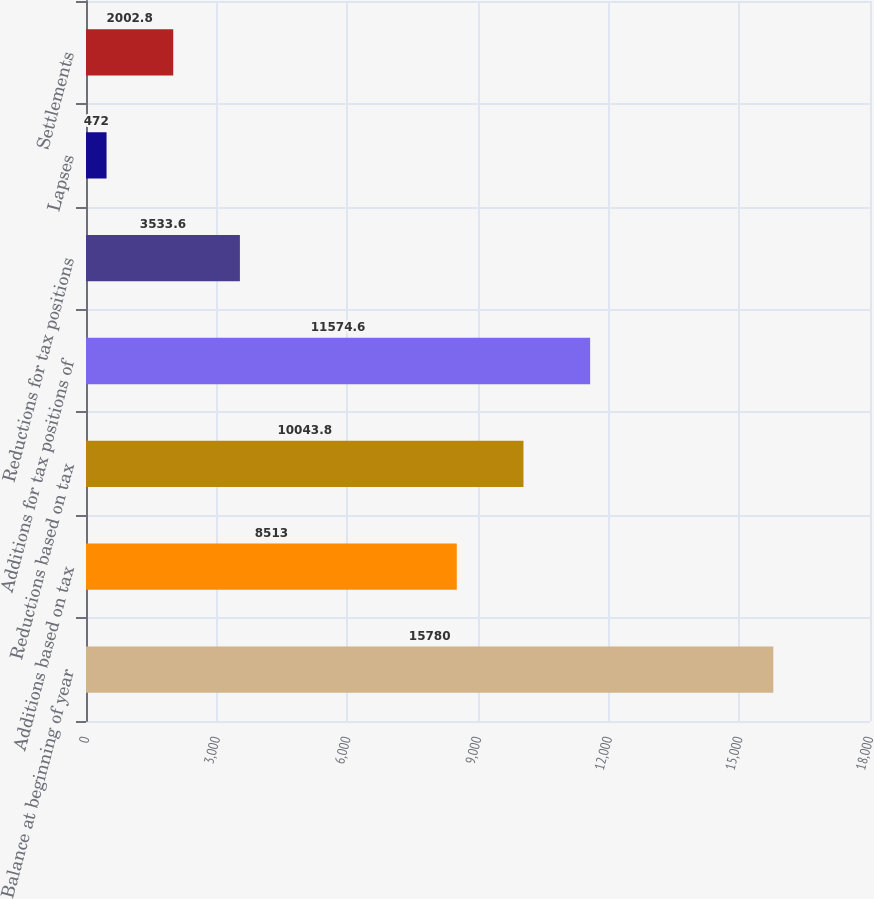Convert chart. <chart><loc_0><loc_0><loc_500><loc_500><bar_chart><fcel>Balance at beginning of year<fcel>Additions based on tax<fcel>Reductions based on tax<fcel>Additions for tax positions of<fcel>Reductions for tax positions<fcel>Lapses<fcel>Settlements<nl><fcel>15780<fcel>8513<fcel>10043.8<fcel>11574.6<fcel>3533.6<fcel>472<fcel>2002.8<nl></chart> 